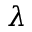Convert formula to latex. <formula><loc_0><loc_0><loc_500><loc_500>\lambda</formula> 